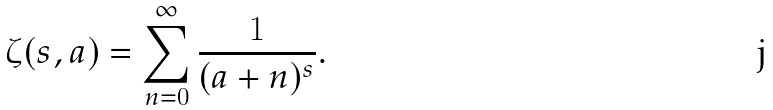<formula> <loc_0><loc_0><loc_500><loc_500>\zeta ( s , a ) = \sum _ { n = 0 } ^ { \infty } \frac { 1 } { ( a + n ) ^ { s } } .</formula> 